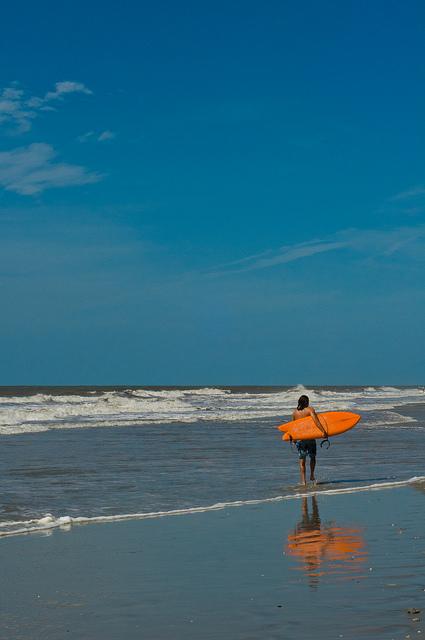What color is the person's surfboard?
Be succinct. Orange. Is it daytime?
Quick response, please. Yes. Where is this body of water?
Give a very brief answer. Ocean. What is in the air?
Quick response, please. Clouds. 